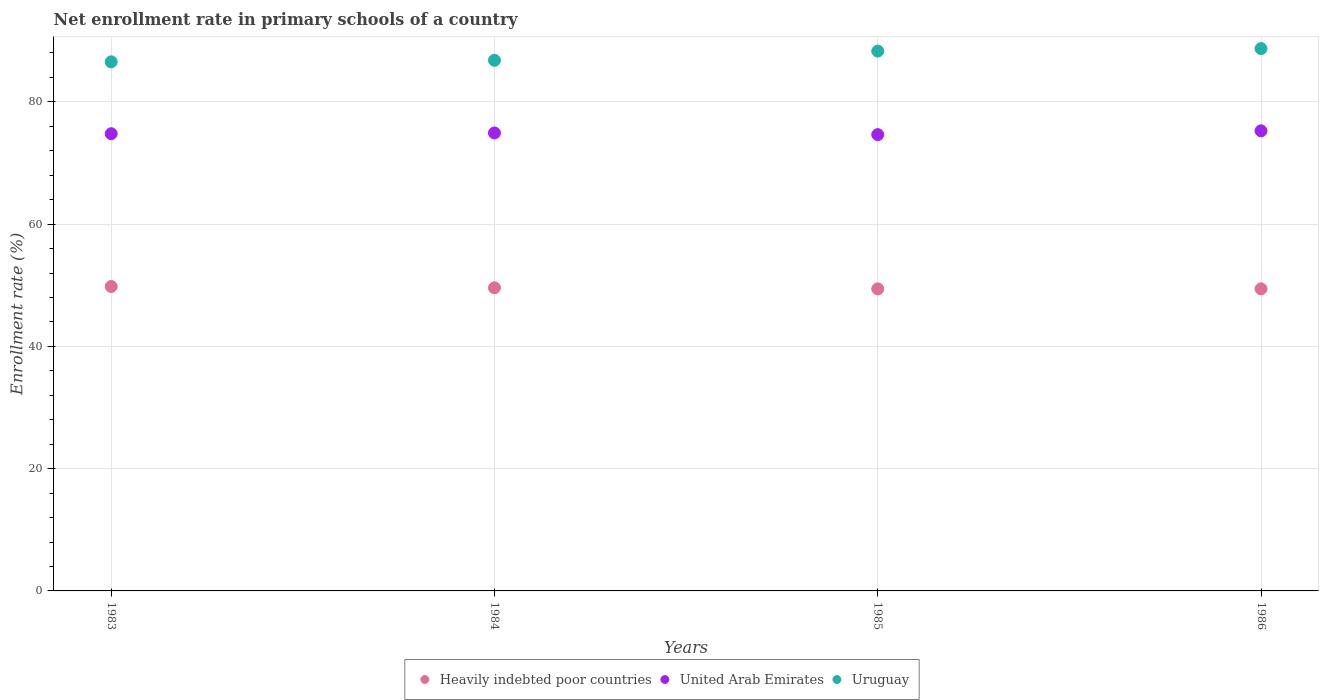How many different coloured dotlines are there?
Offer a terse response. 3. What is the enrollment rate in primary schools in Uruguay in 1985?
Offer a very short reply. 88.31. Across all years, what is the maximum enrollment rate in primary schools in Uruguay?
Make the answer very short. 88.72. Across all years, what is the minimum enrollment rate in primary schools in Heavily indebted poor countries?
Provide a succinct answer. 49.41. What is the total enrollment rate in primary schools in Uruguay in the graph?
Provide a succinct answer. 350.39. What is the difference between the enrollment rate in primary schools in Uruguay in 1985 and that in 1986?
Ensure brevity in your answer.  -0.41. What is the difference between the enrollment rate in primary schools in United Arab Emirates in 1983 and the enrollment rate in primary schools in Uruguay in 1986?
Offer a terse response. -13.92. What is the average enrollment rate in primary schools in Uruguay per year?
Ensure brevity in your answer.  87.6. In the year 1985, what is the difference between the enrollment rate in primary schools in Heavily indebted poor countries and enrollment rate in primary schools in United Arab Emirates?
Ensure brevity in your answer.  -25.24. In how many years, is the enrollment rate in primary schools in Uruguay greater than 68 %?
Your answer should be very brief. 4. What is the ratio of the enrollment rate in primary schools in Uruguay in 1983 to that in 1986?
Make the answer very short. 0.98. What is the difference between the highest and the second highest enrollment rate in primary schools in United Arab Emirates?
Make the answer very short. 0.35. What is the difference between the highest and the lowest enrollment rate in primary schools in United Arab Emirates?
Your answer should be very brief. 0.62. Is the sum of the enrollment rate in primary schools in United Arab Emirates in 1983 and 1984 greater than the maximum enrollment rate in primary schools in Heavily indebted poor countries across all years?
Your answer should be very brief. Yes. Is it the case that in every year, the sum of the enrollment rate in primary schools in Uruguay and enrollment rate in primary schools in Heavily indebted poor countries  is greater than the enrollment rate in primary schools in United Arab Emirates?
Ensure brevity in your answer.  Yes. Is the enrollment rate in primary schools in Heavily indebted poor countries strictly greater than the enrollment rate in primary schools in Uruguay over the years?
Provide a succinct answer. No. Is the enrollment rate in primary schools in United Arab Emirates strictly less than the enrollment rate in primary schools in Uruguay over the years?
Give a very brief answer. Yes. What is the difference between two consecutive major ticks on the Y-axis?
Ensure brevity in your answer.  20. Does the graph contain any zero values?
Offer a terse response. No. Does the graph contain grids?
Provide a short and direct response. Yes. What is the title of the graph?
Your answer should be compact. Net enrollment rate in primary schools of a country. Does "Middle East & North Africa (all income levels)" appear as one of the legend labels in the graph?
Your answer should be very brief. No. What is the label or title of the Y-axis?
Provide a succinct answer. Enrollment rate (%). What is the Enrollment rate (%) in Heavily indebted poor countries in 1983?
Your answer should be very brief. 49.8. What is the Enrollment rate (%) in United Arab Emirates in 1983?
Offer a very short reply. 74.8. What is the Enrollment rate (%) in Uruguay in 1983?
Offer a very short reply. 86.56. What is the Enrollment rate (%) of Heavily indebted poor countries in 1984?
Offer a terse response. 49.59. What is the Enrollment rate (%) in United Arab Emirates in 1984?
Your answer should be very brief. 74.92. What is the Enrollment rate (%) in Uruguay in 1984?
Ensure brevity in your answer.  86.81. What is the Enrollment rate (%) in Heavily indebted poor countries in 1985?
Offer a terse response. 49.41. What is the Enrollment rate (%) in United Arab Emirates in 1985?
Your response must be concise. 74.65. What is the Enrollment rate (%) of Uruguay in 1985?
Offer a terse response. 88.31. What is the Enrollment rate (%) in Heavily indebted poor countries in 1986?
Your answer should be compact. 49.42. What is the Enrollment rate (%) of United Arab Emirates in 1986?
Provide a succinct answer. 75.27. What is the Enrollment rate (%) in Uruguay in 1986?
Offer a very short reply. 88.72. Across all years, what is the maximum Enrollment rate (%) of Heavily indebted poor countries?
Offer a very short reply. 49.8. Across all years, what is the maximum Enrollment rate (%) of United Arab Emirates?
Provide a short and direct response. 75.27. Across all years, what is the maximum Enrollment rate (%) of Uruguay?
Provide a succinct answer. 88.72. Across all years, what is the minimum Enrollment rate (%) in Heavily indebted poor countries?
Ensure brevity in your answer.  49.41. Across all years, what is the minimum Enrollment rate (%) of United Arab Emirates?
Provide a short and direct response. 74.65. Across all years, what is the minimum Enrollment rate (%) of Uruguay?
Provide a succinct answer. 86.56. What is the total Enrollment rate (%) of Heavily indebted poor countries in the graph?
Provide a short and direct response. 198.22. What is the total Enrollment rate (%) of United Arab Emirates in the graph?
Make the answer very short. 299.63. What is the total Enrollment rate (%) in Uruguay in the graph?
Your answer should be compact. 350.39. What is the difference between the Enrollment rate (%) of Heavily indebted poor countries in 1983 and that in 1984?
Offer a very short reply. 0.22. What is the difference between the Enrollment rate (%) in United Arab Emirates in 1983 and that in 1984?
Keep it short and to the point. -0.12. What is the difference between the Enrollment rate (%) in Uruguay in 1983 and that in 1984?
Ensure brevity in your answer.  -0.25. What is the difference between the Enrollment rate (%) of Heavily indebted poor countries in 1983 and that in 1985?
Provide a succinct answer. 0.4. What is the difference between the Enrollment rate (%) in United Arab Emirates in 1983 and that in 1985?
Make the answer very short. 0.15. What is the difference between the Enrollment rate (%) of Uruguay in 1983 and that in 1985?
Your response must be concise. -1.75. What is the difference between the Enrollment rate (%) in Heavily indebted poor countries in 1983 and that in 1986?
Offer a terse response. 0.39. What is the difference between the Enrollment rate (%) of United Arab Emirates in 1983 and that in 1986?
Provide a short and direct response. -0.47. What is the difference between the Enrollment rate (%) of Uruguay in 1983 and that in 1986?
Keep it short and to the point. -2.16. What is the difference between the Enrollment rate (%) in Heavily indebted poor countries in 1984 and that in 1985?
Make the answer very short. 0.18. What is the difference between the Enrollment rate (%) in United Arab Emirates in 1984 and that in 1985?
Give a very brief answer. 0.27. What is the difference between the Enrollment rate (%) of Uruguay in 1984 and that in 1985?
Give a very brief answer. -1.5. What is the difference between the Enrollment rate (%) in Heavily indebted poor countries in 1984 and that in 1986?
Offer a very short reply. 0.17. What is the difference between the Enrollment rate (%) in United Arab Emirates in 1984 and that in 1986?
Offer a terse response. -0.35. What is the difference between the Enrollment rate (%) in Uruguay in 1984 and that in 1986?
Provide a succinct answer. -1.91. What is the difference between the Enrollment rate (%) of Heavily indebted poor countries in 1985 and that in 1986?
Keep it short and to the point. -0.01. What is the difference between the Enrollment rate (%) in United Arab Emirates in 1985 and that in 1986?
Keep it short and to the point. -0.62. What is the difference between the Enrollment rate (%) in Uruguay in 1985 and that in 1986?
Provide a succinct answer. -0.41. What is the difference between the Enrollment rate (%) in Heavily indebted poor countries in 1983 and the Enrollment rate (%) in United Arab Emirates in 1984?
Provide a short and direct response. -25.11. What is the difference between the Enrollment rate (%) of Heavily indebted poor countries in 1983 and the Enrollment rate (%) of Uruguay in 1984?
Your answer should be compact. -37. What is the difference between the Enrollment rate (%) of United Arab Emirates in 1983 and the Enrollment rate (%) of Uruguay in 1984?
Your answer should be very brief. -12.01. What is the difference between the Enrollment rate (%) of Heavily indebted poor countries in 1983 and the Enrollment rate (%) of United Arab Emirates in 1985?
Your answer should be very brief. -24.84. What is the difference between the Enrollment rate (%) of Heavily indebted poor countries in 1983 and the Enrollment rate (%) of Uruguay in 1985?
Make the answer very short. -38.5. What is the difference between the Enrollment rate (%) in United Arab Emirates in 1983 and the Enrollment rate (%) in Uruguay in 1985?
Your answer should be very brief. -13.51. What is the difference between the Enrollment rate (%) in Heavily indebted poor countries in 1983 and the Enrollment rate (%) in United Arab Emirates in 1986?
Offer a very short reply. -25.46. What is the difference between the Enrollment rate (%) in Heavily indebted poor countries in 1983 and the Enrollment rate (%) in Uruguay in 1986?
Give a very brief answer. -38.91. What is the difference between the Enrollment rate (%) in United Arab Emirates in 1983 and the Enrollment rate (%) in Uruguay in 1986?
Make the answer very short. -13.92. What is the difference between the Enrollment rate (%) of Heavily indebted poor countries in 1984 and the Enrollment rate (%) of United Arab Emirates in 1985?
Your response must be concise. -25.06. What is the difference between the Enrollment rate (%) of Heavily indebted poor countries in 1984 and the Enrollment rate (%) of Uruguay in 1985?
Your response must be concise. -38.72. What is the difference between the Enrollment rate (%) of United Arab Emirates in 1984 and the Enrollment rate (%) of Uruguay in 1985?
Provide a succinct answer. -13.39. What is the difference between the Enrollment rate (%) of Heavily indebted poor countries in 1984 and the Enrollment rate (%) of United Arab Emirates in 1986?
Keep it short and to the point. -25.68. What is the difference between the Enrollment rate (%) in Heavily indebted poor countries in 1984 and the Enrollment rate (%) in Uruguay in 1986?
Ensure brevity in your answer.  -39.13. What is the difference between the Enrollment rate (%) of United Arab Emirates in 1984 and the Enrollment rate (%) of Uruguay in 1986?
Offer a very short reply. -13.8. What is the difference between the Enrollment rate (%) in Heavily indebted poor countries in 1985 and the Enrollment rate (%) in United Arab Emirates in 1986?
Your response must be concise. -25.86. What is the difference between the Enrollment rate (%) in Heavily indebted poor countries in 1985 and the Enrollment rate (%) in Uruguay in 1986?
Offer a terse response. -39.31. What is the difference between the Enrollment rate (%) in United Arab Emirates in 1985 and the Enrollment rate (%) in Uruguay in 1986?
Provide a succinct answer. -14.07. What is the average Enrollment rate (%) in Heavily indebted poor countries per year?
Give a very brief answer. 49.55. What is the average Enrollment rate (%) in United Arab Emirates per year?
Your response must be concise. 74.91. What is the average Enrollment rate (%) in Uruguay per year?
Provide a short and direct response. 87.6. In the year 1983, what is the difference between the Enrollment rate (%) of Heavily indebted poor countries and Enrollment rate (%) of United Arab Emirates?
Provide a succinct answer. -24.99. In the year 1983, what is the difference between the Enrollment rate (%) in Heavily indebted poor countries and Enrollment rate (%) in Uruguay?
Provide a succinct answer. -36.75. In the year 1983, what is the difference between the Enrollment rate (%) of United Arab Emirates and Enrollment rate (%) of Uruguay?
Offer a terse response. -11.76. In the year 1984, what is the difference between the Enrollment rate (%) in Heavily indebted poor countries and Enrollment rate (%) in United Arab Emirates?
Your answer should be very brief. -25.33. In the year 1984, what is the difference between the Enrollment rate (%) of Heavily indebted poor countries and Enrollment rate (%) of Uruguay?
Ensure brevity in your answer.  -37.22. In the year 1984, what is the difference between the Enrollment rate (%) of United Arab Emirates and Enrollment rate (%) of Uruguay?
Provide a succinct answer. -11.89. In the year 1985, what is the difference between the Enrollment rate (%) in Heavily indebted poor countries and Enrollment rate (%) in United Arab Emirates?
Your response must be concise. -25.24. In the year 1985, what is the difference between the Enrollment rate (%) in Heavily indebted poor countries and Enrollment rate (%) in Uruguay?
Provide a short and direct response. -38.9. In the year 1985, what is the difference between the Enrollment rate (%) of United Arab Emirates and Enrollment rate (%) of Uruguay?
Make the answer very short. -13.66. In the year 1986, what is the difference between the Enrollment rate (%) of Heavily indebted poor countries and Enrollment rate (%) of United Arab Emirates?
Your answer should be very brief. -25.85. In the year 1986, what is the difference between the Enrollment rate (%) of Heavily indebted poor countries and Enrollment rate (%) of Uruguay?
Offer a terse response. -39.3. In the year 1986, what is the difference between the Enrollment rate (%) of United Arab Emirates and Enrollment rate (%) of Uruguay?
Keep it short and to the point. -13.45. What is the ratio of the Enrollment rate (%) of United Arab Emirates in 1983 to that in 1984?
Your response must be concise. 1. What is the ratio of the Enrollment rate (%) of Uruguay in 1983 to that in 1984?
Your answer should be compact. 1. What is the ratio of the Enrollment rate (%) of Uruguay in 1983 to that in 1985?
Your answer should be compact. 0.98. What is the ratio of the Enrollment rate (%) of Uruguay in 1983 to that in 1986?
Give a very brief answer. 0.98. What is the ratio of the Enrollment rate (%) of United Arab Emirates in 1984 to that in 1985?
Provide a short and direct response. 1. What is the ratio of the Enrollment rate (%) of Uruguay in 1984 to that in 1985?
Give a very brief answer. 0.98. What is the ratio of the Enrollment rate (%) of Uruguay in 1984 to that in 1986?
Your answer should be very brief. 0.98. What is the ratio of the Enrollment rate (%) of Heavily indebted poor countries in 1985 to that in 1986?
Give a very brief answer. 1. What is the ratio of the Enrollment rate (%) of United Arab Emirates in 1985 to that in 1986?
Offer a terse response. 0.99. What is the difference between the highest and the second highest Enrollment rate (%) of Heavily indebted poor countries?
Offer a terse response. 0.22. What is the difference between the highest and the second highest Enrollment rate (%) in United Arab Emirates?
Offer a very short reply. 0.35. What is the difference between the highest and the second highest Enrollment rate (%) of Uruguay?
Give a very brief answer. 0.41. What is the difference between the highest and the lowest Enrollment rate (%) in Heavily indebted poor countries?
Provide a short and direct response. 0.4. What is the difference between the highest and the lowest Enrollment rate (%) of United Arab Emirates?
Your response must be concise. 0.62. What is the difference between the highest and the lowest Enrollment rate (%) in Uruguay?
Offer a very short reply. 2.16. 